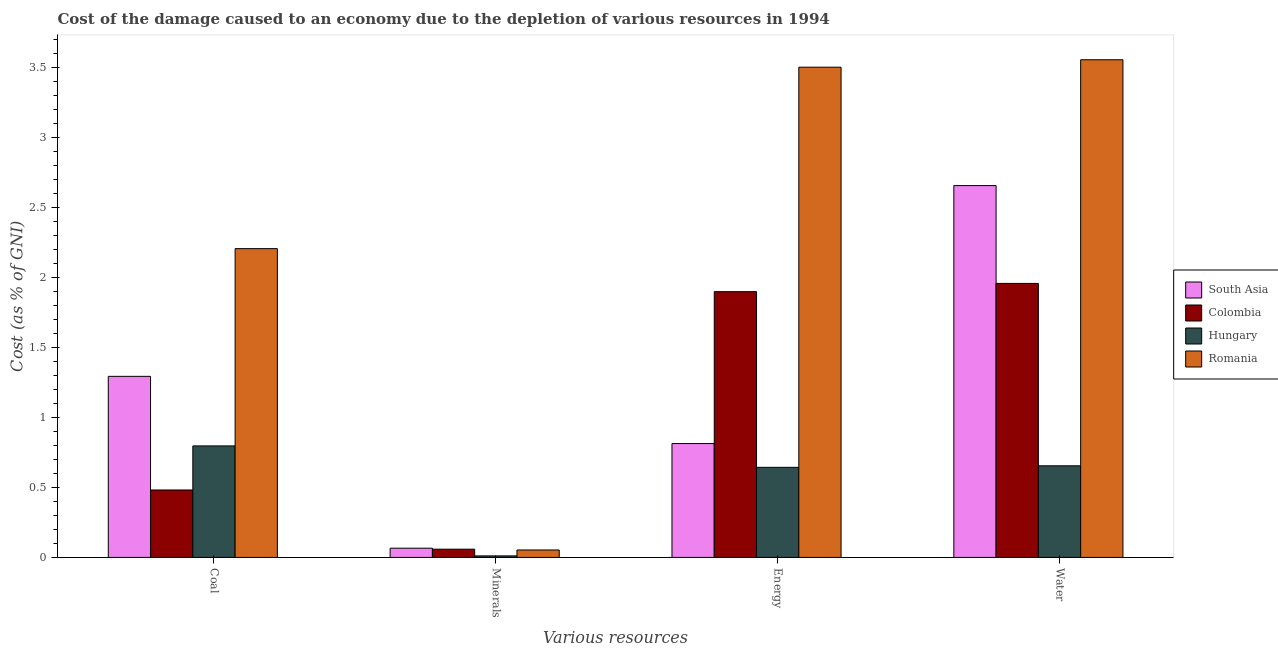Are the number of bars per tick equal to the number of legend labels?
Make the answer very short. Yes. Are the number of bars on each tick of the X-axis equal?
Offer a terse response. Yes. How many bars are there on the 4th tick from the left?
Offer a terse response. 4. How many bars are there on the 2nd tick from the right?
Your answer should be very brief. 4. What is the label of the 3rd group of bars from the left?
Ensure brevity in your answer.  Energy. What is the cost of damage due to depletion of coal in South Asia?
Offer a terse response. 1.29. Across all countries, what is the maximum cost of damage due to depletion of coal?
Your answer should be compact. 2.21. Across all countries, what is the minimum cost of damage due to depletion of minerals?
Your answer should be very brief. 0.01. In which country was the cost of damage due to depletion of energy maximum?
Offer a very short reply. Romania. What is the total cost of damage due to depletion of energy in the graph?
Ensure brevity in your answer.  6.86. What is the difference between the cost of damage due to depletion of water in Hungary and that in South Asia?
Give a very brief answer. -2. What is the difference between the cost of damage due to depletion of minerals in Romania and the cost of damage due to depletion of coal in Colombia?
Keep it short and to the point. -0.43. What is the average cost of damage due to depletion of minerals per country?
Give a very brief answer. 0.05. What is the difference between the cost of damage due to depletion of energy and cost of damage due to depletion of coal in Romania?
Make the answer very short. 1.3. In how many countries, is the cost of damage due to depletion of coal greater than 0.4 %?
Your response must be concise. 4. What is the ratio of the cost of damage due to depletion of water in Colombia to that in South Asia?
Keep it short and to the point. 0.74. Is the cost of damage due to depletion of energy in Romania less than that in South Asia?
Ensure brevity in your answer.  No. Is the difference between the cost of damage due to depletion of minerals in Colombia and Romania greater than the difference between the cost of damage due to depletion of water in Colombia and Romania?
Ensure brevity in your answer.  Yes. What is the difference between the highest and the second highest cost of damage due to depletion of water?
Make the answer very short. 0.9. What is the difference between the highest and the lowest cost of damage due to depletion of coal?
Give a very brief answer. 1.72. In how many countries, is the cost of damage due to depletion of coal greater than the average cost of damage due to depletion of coal taken over all countries?
Offer a terse response. 2. What does the 2nd bar from the left in Energy represents?
Your answer should be very brief. Colombia. What does the 2nd bar from the right in Energy represents?
Keep it short and to the point. Hungary. Is it the case that in every country, the sum of the cost of damage due to depletion of coal and cost of damage due to depletion of minerals is greater than the cost of damage due to depletion of energy?
Offer a terse response. No. How many bars are there?
Your response must be concise. 16. What is the difference between two consecutive major ticks on the Y-axis?
Make the answer very short. 0.5. Are the values on the major ticks of Y-axis written in scientific E-notation?
Ensure brevity in your answer.  No. Does the graph contain grids?
Give a very brief answer. No. Where does the legend appear in the graph?
Ensure brevity in your answer.  Center right. What is the title of the graph?
Your answer should be compact. Cost of the damage caused to an economy due to the depletion of various resources in 1994 . What is the label or title of the X-axis?
Make the answer very short. Various resources. What is the label or title of the Y-axis?
Your response must be concise. Cost (as % of GNI). What is the Cost (as % of GNI) of South Asia in Coal?
Offer a very short reply. 1.29. What is the Cost (as % of GNI) in Colombia in Coal?
Offer a terse response. 0.48. What is the Cost (as % of GNI) in Hungary in Coal?
Your response must be concise. 0.8. What is the Cost (as % of GNI) of Romania in Coal?
Keep it short and to the point. 2.21. What is the Cost (as % of GNI) in South Asia in Minerals?
Give a very brief answer. 0.07. What is the Cost (as % of GNI) in Colombia in Minerals?
Provide a succinct answer. 0.06. What is the Cost (as % of GNI) of Hungary in Minerals?
Your answer should be very brief. 0.01. What is the Cost (as % of GNI) in Romania in Minerals?
Provide a succinct answer. 0.05. What is the Cost (as % of GNI) in South Asia in Energy?
Give a very brief answer. 0.81. What is the Cost (as % of GNI) in Colombia in Energy?
Provide a succinct answer. 1.9. What is the Cost (as % of GNI) in Hungary in Energy?
Provide a succinct answer. 0.64. What is the Cost (as % of GNI) of Romania in Energy?
Give a very brief answer. 3.5. What is the Cost (as % of GNI) of South Asia in Water?
Your answer should be compact. 2.66. What is the Cost (as % of GNI) in Colombia in Water?
Offer a terse response. 1.96. What is the Cost (as % of GNI) in Hungary in Water?
Your answer should be compact. 0.65. What is the Cost (as % of GNI) in Romania in Water?
Your answer should be very brief. 3.55. Across all Various resources, what is the maximum Cost (as % of GNI) of South Asia?
Keep it short and to the point. 2.66. Across all Various resources, what is the maximum Cost (as % of GNI) of Colombia?
Your answer should be very brief. 1.96. Across all Various resources, what is the maximum Cost (as % of GNI) of Hungary?
Make the answer very short. 0.8. Across all Various resources, what is the maximum Cost (as % of GNI) of Romania?
Your answer should be compact. 3.55. Across all Various resources, what is the minimum Cost (as % of GNI) of South Asia?
Keep it short and to the point. 0.07. Across all Various resources, what is the minimum Cost (as % of GNI) of Colombia?
Ensure brevity in your answer.  0.06. Across all Various resources, what is the minimum Cost (as % of GNI) of Hungary?
Make the answer very short. 0.01. Across all Various resources, what is the minimum Cost (as % of GNI) of Romania?
Provide a short and direct response. 0.05. What is the total Cost (as % of GNI) in South Asia in the graph?
Give a very brief answer. 4.83. What is the total Cost (as % of GNI) of Colombia in the graph?
Provide a short and direct response. 4.4. What is the total Cost (as % of GNI) in Hungary in the graph?
Keep it short and to the point. 2.1. What is the total Cost (as % of GNI) in Romania in the graph?
Make the answer very short. 9.31. What is the difference between the Cost (as % of GNI) in South Asia in Coal and that in Minerals?
Provide a succinct answer. 1.23. What is the difference between the Cost (as % of GNI) in Colombia in Coal and that in Minerals?
Offer a terse response. 0.42. What is the difference between the Cost (as % of GNI) of Hungary in Coal and that in Minerals?
Provide a short and direct response. 0.79. What is the difference between the Cost (as % of GNI) of Romania in Coal and that in Minerals?
Offer a terse response. 2.15. What is the difference between the Cost (as % of GNI) in South Asia in Coal and that in Energy?
Ensure brevity in your answer.  0.48. What is the difference between the Cost (as % of GNI) in Colombia in Coal and that in Energy?
Your answer should be very brief. -1.42. What is the difference between the Cost (as % of GNI) of Hungary in Coal and that in Energy?
Offer a terse response. 0.15. What is the difference between the Cost (as % of GNI) of Romania in Coal and that in Energy?
Provide a succinct answer. -1.3. What is the difference between the Cost (as % of GNI) in South Asia in Coal and that in Water?
Ensure brevity in your answer.  -1.36. What is the difference between the Cost (as % of GNI) of Colombia in Coal and that in Water?
Keep it short and to the point. -1.48. What is the difference between the Cost (as % of GNI) in Hungary in Coal and that in Water?
Your answer should be compact. 0.14. What is the difference between the Cost (as % of GNI) in Romania in Coal and that in Water?
Keep it short and to the point. -1.35. What is the difference between the Cost (as % of GNI) of South Asia in Minerals and that in Energy?
Offer a terse response. -0.75. What is the difference between the Cost (as % of GNI) in Colombia in Minerals and that in Energy?
Keep it short and to the point. -1.84. What is the difference between the Cost (as % of GNI) in Hungary in Minerals and that in Energy?
Keep it short and to the point. -0.63. What is the difference between the Cost (as % of GNI) of Romania in Minerals and that in Energy?
Your response must be concise. -3.45. What is the difference between the Cost (as % of GNI) in South Asia in Minerals and that in Water?
Your answer should be very brief. -2.59. What is the difference between the Cost (as % of GNI) in Colombia in Minerals and that in Water?
Ensure brevity in your answer.  -1.9. What is the difference between the Cost (as % of GNI) of Hungary in Minerals and that in Water?
Ensure brevity in your answer.  -0.64. What is the difference between the Cost (as % of GNI) in Romania in Minerals and that in Water?
Your answer should be compact. -3.5. What is the difference between the Cost (as % of GNI) of South Asia in Energy and that in Water?
Keep it short and to the point. -1.84. What is the difference between the Cost (as % of GNI) of Colombia in Energy and that in Water?
Offer a terse response. -0.06. What is the difference between the Cost (as % of GNI) of Hungary in Energy and that in Water?
Your answer should be very brief. -0.01. What is the difference between the Cost (as % of GNI) in Romania in Energy and that in Water?
Make the answer very short. -0.05. What is the difference between the Cost (as % of GNI) in South Asia in Coal and the Cost (as % of GNI) in Colombia in Minerals?
Ensure brevity in your answer.  1.23. What is the difference between the Cost (as % of GNI) in South Asia in Coal and the Cost (as % of GNI) in Hungary in Minerals?
Give a very brief answer. 1.28. What is the difference between the Cost (as % of GNI) of South Asia in Coal and the Cost (as % of GNI) of Romania in Minerals?
Your response must be concise. 1.24. What is the difference between the Cost (as % of GNI) of Colombia in Coal and the Cost (as % of GNI) of Hungary in Minerals?
Give a very brief answer. 0.47. What is the difference between the Cost (as % of GNI) of Colombia in Coal and the Cost (as % of GNI) of Romania in Minerals?
Your answer should be compact. 0.43. What is the difference between the Cost (as % of GNI) in Hungary in Coal and the Cost (as % of GNI) in Romania in Minerals?
Ensure brevity in your answer.  0.74. What is the difference between the Cost (as % of GNI) of South Asia in Coal and the Cost (as % of GNI) of Colombia in Energy?
Your answer should be compact. -0.6. What is the difference between the Cost (as % of GNI) in South Asia in Coal and the Cost (as % of GNI) in Hungary in Energy?
Offer a terse response. 0.65. What is the difference between the Cost (as % of GNI) in South Asia in Coal and the Cost (as % of GNI) in Romania in Energy?
Give a very brief answer. -2.21. What is the difference between the Cost (as % of GNI) in Colombia in Coal and the Cost (as % of GNI) in Hungary in Energy?
Provide a succinct answer. -0.16. What is the difference between the Cost (as % of GNI) in Colombia in Coal and the Cost (as % of GNI) in Romania in Energy?
Keep it short and to the point. -3.02. What is the difference between the Cost (as % of GNI) in Hungary in Coal and the Cost (as % of GNI) in Romania in Energy?
Keep it short and to the point. -2.7. What is the difference between the Cost (as % of GNI) of South Asia in Coal and the Cost (as % of GNI) of Colombia in Water?
Offer a terse response. -0.66. What is the difference between the Cost (as % of GNI) in South Asia in Coal and the Cost (as % of GNI) in Hungary in Water?
Offer a very short reply. 0.64. What is the difference between the Cost (as % of GNI) in South Asia in Coal and the Cost (as % of GNI) in Romania in Water?
Ensure brevity in your answer.  -2.26. What is the difference between the Cost (as % of GNI) in Colombia in Coal and the Cost (as % of GNI) in Hungary in Water?
Your answer should be compact. -0.17. What is the difference between the Cost (as % of GNI) of Colombia in Coal and the Cost (as % of GNI) of Romania in Water?
Your answer should be compact. -3.07. What is the difference between the Cost (as % of GNI) of Hungary in Coal and the Cost (as % of GNI) of Romania in Water?
Your response must be concise. -2.76. What is the difference between the Cost (as % of GNI) of South Asia in Minerals and the Cost (as % of GNI) of Colombia in Energy?
Offer a very short reply. -1.83. What is the difference between the Cost (as % of GNI) of South Asia in Minerals and the Cost (as % of GNI) of Hungary in Energy?
Keep it short and to the point. -0.58. What is the difference between the Cost (as % of GNI) of South Asia in Minerals and the Cost (as % of GNI) of Romania in Energy?
Ensure brevity in your answer.  -3.44. What is the difference between the Cost (as % of GNI) of Colombia in Minerals and the Cost (as % of GNI) of Hungary in Energy?
Provide a succinct answer. -0.58. What is the difference between the Cost (as % of GNI) in Colombia in Minerals and the Cost (as % of GNI) in Romania in Energy?
Provide a short and direct response. -3.44. What is the difference between the Cost (as % of GNI) of Hungary in Minerals and the Cost (as % of GNI) of Romania in Energy?
Give a very brief answer. -3.49. What is the difference between the Cost (as % of GNI) in South Asia in Minerals and the Cost (as % of GNI) in Colombia in Water?
Keep it short and to the point. -1.89. What is the difference between the Cost (as % of GNI) in South Asia in Minerals and the Cost (as % of GNI) in Hungary in Water?
Ensure brevity in your answer.  -0.59. What is the difference between the Cost (as % of GNI) of South Asia in Minerals and the Cost (as % of GNI) of Romania in Water?
Provide a short and direct response. -3.49. What is the difference between the Cost (as % of GNI) of Colombia in Minerals and the Cost (as % of GNI) of Hungary in Water?
Provide a short and direct response. -0.6. What is the difference between the Cost (as % of GNI) in Colombia in Minerals and the Cost (as % of GNI) in Romania in Water?
Keep it short and to the point. -3.5. What is the difference between the Cost (as % of GNI) in Hungary in Minerals and the Cost (as % of GNI) in Romania in Water?
Keep it short and to the point. -3.54. What is the difference between the Cost (as % of GNI) in South Asia in Energy and the Cost (as % of GNI) in Colombia in Water?
Your answer should be very brief. -1.14. What is the difference between the Cost (as % of GNI) in South Asia in Energy and the Cost (as % of GNI) in Hungary in Water?
Keep it short and to the point. 0.16. What is the difference between the Cost (as % of GNI) of South Asia in Energy and the Cost (as % of GNI) of Romania in Water?
Your response must be concise. -2.74. What is the difference between the Cost (as % of GNI) in Colombia in Energy and the Cost (as % of GNI) in Hungary in Water?
Ensure brevity in your answer.  1.24. What is the difference between the Cost (as % of GNI) in Colombia in Energy and the Cost (as % of GNI) in Romania in Water?
Provide a succinct answer. -1.66. What is the difference between the Cost (as % of GNI) of Hungary in Energy and the Cost (as % of GNI) of Romania in Water?
Your answer should be very brief. -2.91. What is the average Cost (as % of GNI) of South Asia per Various resources?
Your response must be concise. 1.21. What is the average Cost (as % of GNI) of Colombia per Various resources?
Provide a succinct answer. 1.1. What is the average Cost (as % of GNI) of Hungary per Various resources?
Give a very brief answer. 0.53. What is the average Cost (as % of GNI) in Romania per Various resources?
Offer a very short reply. 2.33. What is the difference between the Cost (as % of GNI) of South Asia and Cost (as % of GNI) of Colombia in Coal?
Offer a terse response. 0.81. What is the difference between the Cost (as % of GNI) in South Asia and Cost (as % of GNI) in Hungary in Coal?
Your response must be concise. 0.5. What is the difference between the Cost (as % of GNI) in South Asia and Cost (as % of GNI) in Romania in Coal?
Give a very brief answer. -0.91. What is the difference between the Cost (as % of GNI) of Colombia and Cost (as % of GNI) of Hungary in Coal?
Offer a terse response. -0.31. What is the difference between the Cost (as % of GNI) in Colombia and Cost (as % of GNI) in Romania in Coal?
Offer a terse response. -1.72. What is the difference between the Cost (as % of GNI) of Hungary and Cost (as % of GNI) of Romania in Coal?
Offer a terse response. -1.41. What is the difference between the Cost (as % of GNI) in South Asia and Cost (as % of GNI) in Colombia in Minerals?
Offer a very short reply. 0.01. What is the difference between the Cost (as % of GNI) in South Asia and Cost (as % of GNI) in Hungary in Minerals?
Offer a very short reply. 0.06. What is the difference between the Cost (as % of GNI) in South Asia and Cost (as % of GNI) in Romania in Minerals?
Ensure brevity in your answer.  0.01. What is the difference between the Cost (as % of GNI) in Colombia and Cost (as % of GNI) in Hungary in Minerals?
Offer a very short reply. 0.05. What is the difference between the Cost (as % of GNI) of Colombia and Cost (as % of GNI) of Romania in Minerals?
Your answer should be compact. 0.01. What is the difference between the Cost (as % of GNI) in Hungary and Cost (as % of GNI) in Romania in Minerals?
Provide a short and direct response. -0.04. What is the difference between the Cost (as % of GNI) in South Asia and Cost (as % of GNI) in Colombia in Energy?
Your answer should be very brief. -1.08. What is the difference between the Cost (as % of GNI) of South Asia and Cost (as % of GNI) of Hungary in Energy?
Give a very brief answer. 0.17. What is the difference between the Cost (as % of GNI) of South Asia and Cost (as % of GNI) of Romania in Energy?
Provide a short and direct response. -2.69. What is the difference between the Cost (as % of GNI) of Colombia and Cost (as % of GNI) of Hungary in Energy?
Provide a succinct answer. 1.25. What is the difference between the Cost (as % of GNI) in Colombia and Cost (as % of GNI) in Romania in Energy?
Offer a very short reply. -1.6. What is the difference between the Cost (as % of GNI) in Hungary and Cost (as % of GNI) in Romania in Energy?
Provide a succinct answer. -2.86. What is the difference between the Cost (as % of GNI) of South Asia and Cost (as % of GNI) of Colombia in Water?
Offer a terse response. 0.7. What is the difference between the Cost (as % of GNI) of South Asia and Cost (as % of GNI) of Hungary in Water?
Provide a short and direct response. 2. What is the difference between the Cost (as % of GNI) of South Asia and Cost (as % of GNI) of Romania in Water?
Offer a terse response. -0.9. What is the difference between the Cost (as % of GNI) in Colombia and Cost (as % of GNI) in Hungary in Water?
Provide a succinct answer. 1.3. What is the difference between the Cost (as % of GNI) in Colombia and Cost (as % of GNI) in Romania in Water?
Your answer should be compact. -1.6. What is the difference between the Cost (as % of GNI) in Hungary and Cost (as % of GNI) in Romania in Water?
Keep it short and to the point. -2.9. What is the ratio of the Cost (as % of GNI) in South Asia in Coal to that in Minerals?
Make the answer very short. 19.63. What is the ratio of the Cost (as % of GNI) of Colombia in Coal to that in Minerals?
Provide a succinct answer. 8.19. What is the ratio of the Cost (as % of GNI) of Hungary in Coal to that in Minerals?
Provide a short and direct response. 73.27. What is the ratio of the Cost (as % of GNI) in Romania in Coal to that in Minerals?
Your response must be concise. 41.48. What is the ratio of the Cost (as % of GNI) in South Asia in Coal to that in Energy?
Give a very brief answer. 1.59. What is the ratio of the Cost (as % of GNI) in Colombia in Coal to that in Energy?
Offer a terse response. 0.25. What is the ratio of the Cost (as % of GNI) in Hungary in Coal to that in Energy?
Keep it short and to the point. 1.24. What is the ratio of the Cost (as % of GNI) of Romania in Coal to that in Energy?
Keep it short and to the point. 0.63. What is the ratio of the Cost (as % of GNI) of South Asia in Coal to that in Water?
Offer a terse response. 0.49. What is the ratio of the Cost (as % of GNI) of Colombia in Coal to that in Water?
Keep it short and to the point. 0.25. What is the ratio of the Cost (as % of GNI) of Hungary in Coal to that in Water?
Your answer should be very brief. 1.22. What is the ratio of the Cost (as % of GNI) in Romania in Coal to that in Water?
Your answer should be compact. 0.62. What is the ratio of the Cost (as % of GNI) in South Asia in Minerals to that in Energy?
Give a very brief answer. 0.08. What is the ratio of the Cost (as % of GNI) of Colombia in Minerals to that in Energy?
Give a very brief answer. 0.03. What is the ratio of the Cost (as % of GNI) of Hungary in Minerals to that in Energy?
Offer a very short reply. 0.02. What is the ratio of the Cost (as % of GNI) in Romania in Minerals to that in Energy?
Offer a very short reply. 0.02. What is the ratio of the Cost (as % of GNI) in South Asia in Minerals to that in Water?
Keep it short and to the point. 0.02. What is the ratio of the Cost (as % of GNI) in Colombia in Minerals to that in Water?
Provide a succinct answer. 0.03. What is the ratio of the Cost (as % of GNI) in Hungary in Minerals to that in Water?
Provide a short and direct response. 0.02. What is the ratio of the Cost (as % of GNI) in Romania in Minerals to that in Water?
Provide a succinct answer. 0.01. What is the ratio of the Cost (as % of GNI) in South Asia in Energy to that in Water?
Ensure brevity in your answer.  0.31. What is the ratio of the Cost (as % of GNI) in Colombia in Energy to that in Water?
Your answer should be compact. 0.97. What is the ratio of the Cost (as % of GNI) in Hungary in Energy to that in Water?
Your answer should be very brief. 0.98. What is the difference between the highest and the second highest Cost (as % of GNI) of South Asia?
Your response must be concise. 1.36. What is the difference between the highest and the second highest Cost (as % of GNI) of Colombia?
Your answer should be very brief. 0.06. What is the difference between the highest and the second highest Cost (as % of GNI) in Hungary?
Provide a short and direct response. 0.14. What is the difference between the highest and the second highest Cost (as % of GNI) of Romania?
Ensure brevity in your answer.  0.05. What is the difference between the highest and the lowest Cost (as % of GNI) in South Asia?
Ensure brevity in your answer.  2.59. What is the difference between the highest and the lowest Cost (as % of GNI) in Colombia?
Your response must be concise. 1.9. What is the difference between the highest and the lowest Cost (as % of GNI) of Hungary?
Provide a succinct answer. 0.79. What is the difference between the highest and the lowest Cost (as % of GNI) in Romania?
Keep it short and to the point. 3.5. 